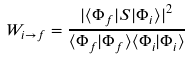Convert formula to latex. <formula><loc_0><loc_0><loc_500><loc_500>W _ { i \rightarrow f } = { \frac { { | \langle \Phi _ { f } | S | \Phi _ { i } \rangle | } ^ { 2 } } { \langle \Phi _ { f } | \Phi _ { f } \rangle \langle \Phi _ { i } | \Phi _ { i } \rangle } }</formula> 